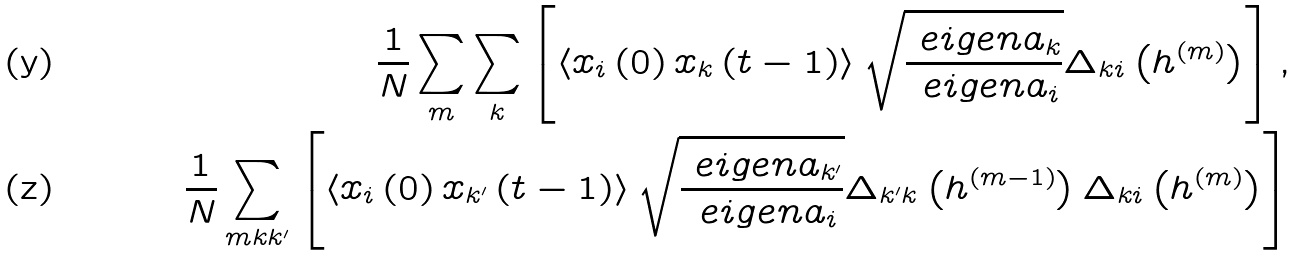Convert formula to latex. <formula><loc_0><loc_0><loc_500><loc_500>\frac { 1 } { N } \sum _ { m } \sum _ { k } \left [ \left < x _ { i } \left ( 0 \right ) x _ { k } \left ( t - 1 \right ) \right > \sqrt { \frac { \ e i g e n a _ { k } } { \ e i g e n a _ { i } } } \Delta _ { k i } \left ( { h } ^ { ( m ) } \right ) \right ] , \\ \frac { 1 } { N } \sum _ { m k k ^ { \prime } } \left [ \left < x _ { i } \left ( 0 \right ) x _ { k ^ { \prime } } \left ( t - 1 \right ) \right > \sqrt { \frac { \ e i g e n a _ { k ^ { \prime } } } { \ e i g e n a _ { i } } } \Delta _ { k ^ { \prime } k } \left ( { h } ^ { ( m - 1 ) } \right ) \Delta _ { k i } \left ( { h } ^ { ( m ) } \right ) \right ]</formula> 